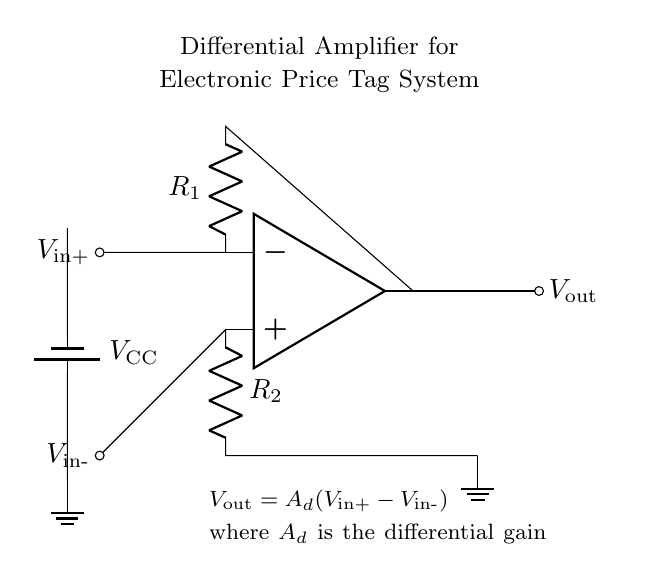What type of amplifier is depicted in the diagram? The circuit is a differential amplifier, indicated by the specific configurations of its inputs and outputs labeled as Vin+ and Vin-.
Answer: differential amplifier What are the two input voltages for this amplifier? The input voltages are V_in+ and V_in-, which are connected to the inverting and non-inverting terminals respectively as shown in the circuit.
Answer: V_in+ and V_in- What is the equation for the output voltage of this amplifier? The output voltage is defined by the equation V_out = A_d(V_in+ - V_in-), where A_d represents the differential gain and is specified in the circuit notes.
Answer: V_out = A_d(V_in+ - V_in-) How many resistors are present in the circuit? There are two resistors labeled R_1 and R_2 in the circuit connected to the respective inputs and output of the amplifier.
Answer: 2 What is the role of resistors R_1 and R_2? Resistors R_1 and R_2 set the gain of the differential amplifier and influence the output voltage based on the difference between V_in+ and V_in-.
Answer: Gain setting What is the purpose of the V_CC battery in the circuit? V_CC provides the necessary power or supply voltage for the operational amplifier's function, ensuring it operates properly within its required voltage range.
Answer: Power supply What is the function of the ground in this circuit? The ground serves as a reference point for the voltages in the circuit, establishing a common return path for current and ensuring stable operation of the amplifier.
Answer: Reference point 